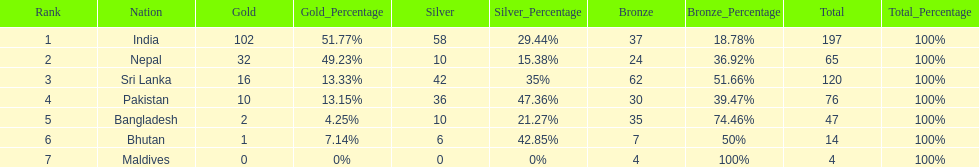What country has won no silver medals? Maldives. 